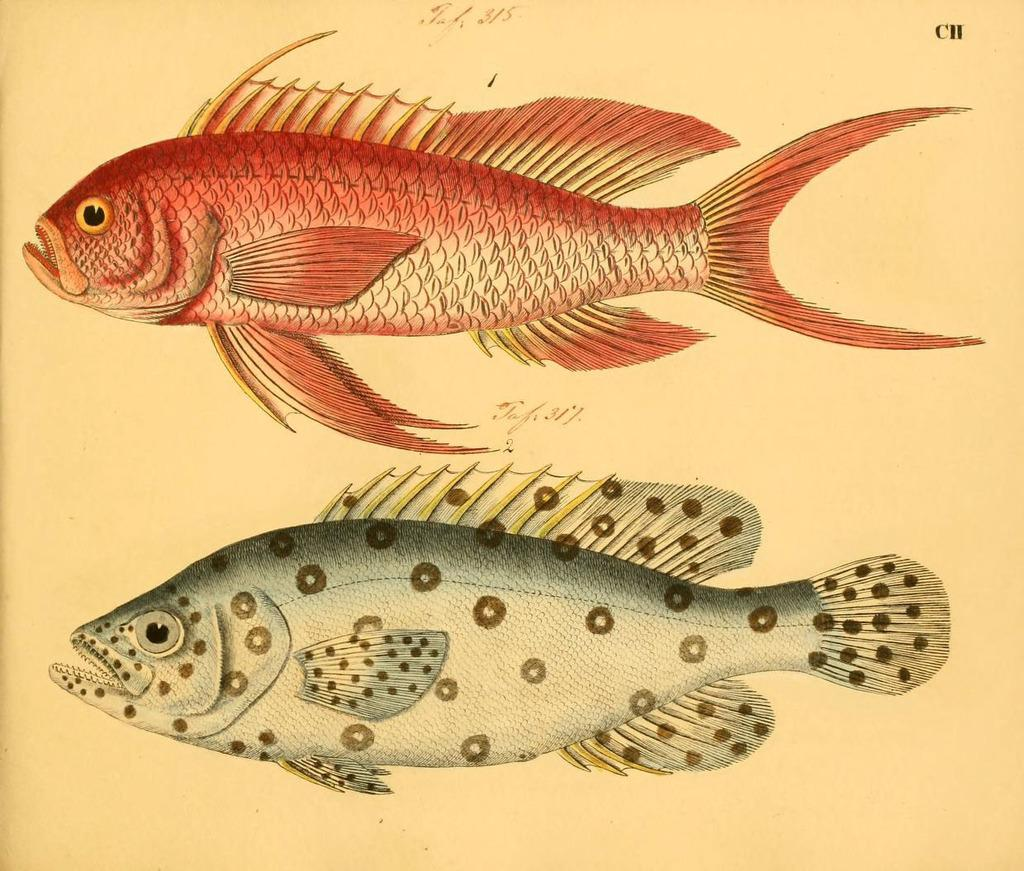What is depicted on the paper in the image? The painted paper in the image features fishes. What type of artwork is shown on the paper? The artwork is a painting of fishes. What type of ornament is hanging from the ceiling in the image? There is no ornament hanging from the ceiling in the image; it only features a painted paper with fishes. What type of quartz is present on the table in the image? There is no quartz present in the image; it only features a painted paper with fishes. 